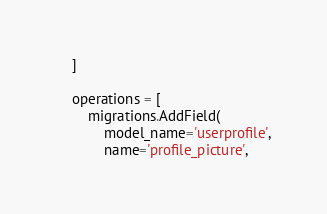Convert code to text. <code><loc_0><loc_0><loc_500><loc_500><_Python_>    ]

    operations = [
        migrations.AddField(
            model_name='userprofile',
            name='profile_picture',</code> 